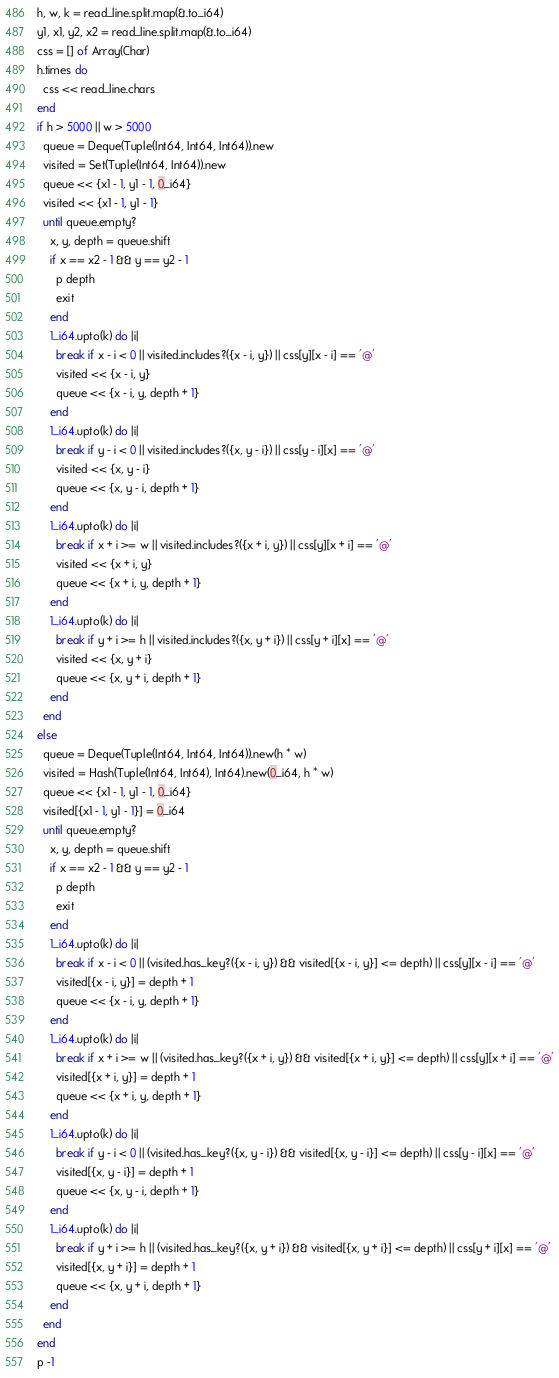Convert code to text. <code><loc_0><loc_0><loc_500><loc_500><_Crystal_>h, w, k = read_line.split.map(&.to_i64)
y1, x1, y2, x2 = read_line.split.map(&.to_i64)
css = [] of Array(Char)
h.times do
  css << read_line.chars
end
if h > 5000 || w > 5000
  queue = Deque(Tuple(Int64, Int64, Int64)).new
  visited = Set(Tuple(Int64, Int64)).new
  queue << {x1 - 1, y1 - 1, 0_i64}
  visited << {x1 - 1, y1 - 1}
  until queue.empty?
    x, y, depth = queue.shift
    if x == x2 - 1 && y == y2 - 1
      p depth
      exit
    end
    1_i64.upto(k) do |i|
      break if x - i < 0 || visited.includes?({x - i, y}) || css[y][x - i] == '@'
      visited << {x - i, y}
      queue << {x - i, y, depth + 1}
    end
    1_i64.upto(k) do |i|
      break if y - i < 0 || visited.includes?({x, y - i}) || css[y - i][x] == '@'
      visited << {x, y - i}
      queue << {x, y - i, depth + 1}
    end
    1_i64.upto(k) do |i|
      break if x + i >= w || visited.includes?({x + i, y}) || css[y][x + i] == '@'
      visited << {x + i, y}
      queue << {x + i, y, depth + 1}
    end
    1_i64.upto(k) do |i|
      break if y + i >= h || visited.includes?({x, y + i}) || css[y + i][x] == '@'
      visited << {x, y + i}
      queue << {x, y + i, depth + 1}
    end
  end
else
  queue = Deque(Tuple(Int64, Int64, Int64)).new(h * w)
  visited = Hash(Tuple(Int64, Int64), Int64).new(0_i64, h * w)
  queue << {x1 - 1, y1 - 1, 0_i64}
  visited[{x1 - 1, y1 - 1}] = 0_i64
  until queue.empty?
    x, y, depth = queue.shift
    if x == x2 - 1 && y == y2 - 1
      p depth
      exit
    end
    1_i64.upto(k) do |i|
      break if x - i < 0 || (visited.has_key?({x - i, y}) && visited[{x - i, y}] <= depth) || css[y][x - i] == '@'
      visited[{x - i, y}] = depth + 1
      queue << {x - i, y, depth + 1}
    end
    1_i64.upto(k) do |i|
      break if x + i >= w || (visited.has_key?({x + i, y}) && visited[{x + i, y}] <= depth) || css[y][x + i] == '@'
      visited[{x + i, y}] = depth + 1
      queue << {x + i, y, depth + 1}
    end
    1_i64.upto(k) do |i|
      break if y - i < 0 || (visited.has_key?({x, y - i}) && visited[{x, y - i}] <= depth) || css[y - i][x] == '@'
      visited[{x, y - i}] = depth + 1
      queue << {x, y - i, depth + 1}
    end
    1_i64.upto(k) do |i|
      break if y + i >= h || (visited.has_key?({x, y + i}) && visited[{x, y + i}] <= depth) || css[y + i][x] == '@'
      visited[{x, y + i}] = depth + 1
      queue << {x, y + i, depth + 1}
    end
  end
end
p -1
</code> 